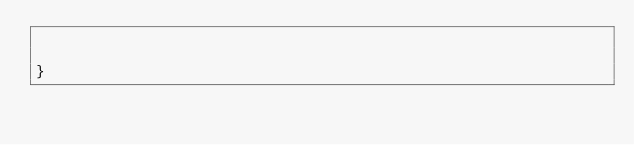Convert code to text. <code><loc_0><loc_0><loc_500><loc_500><_JavaScript_>

}
</code> 